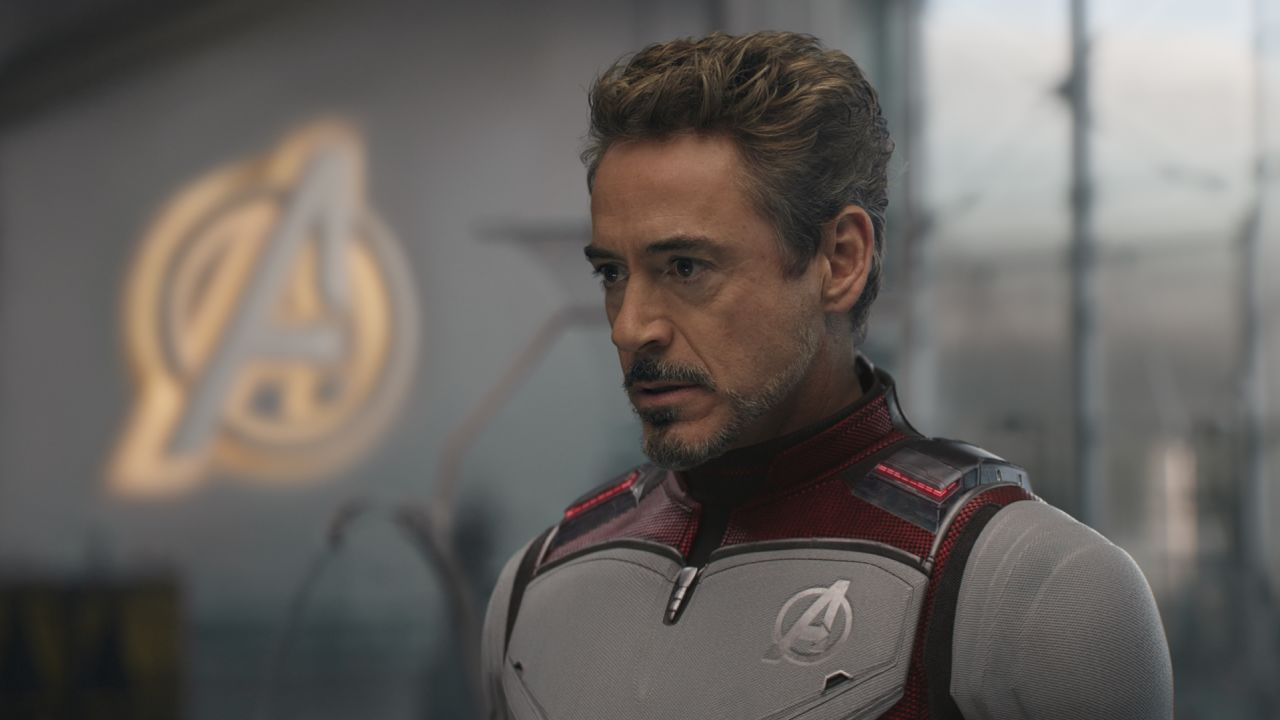What is this photo about? This photo captures a striking image of Tony Stark, a character from the Marvel Cinematic Universe, portrayed by Robert Downey Jr. He is dressed in his distinctive Avengers suit, which is carefully detailed with the iconic Avengers logo on the chest. Behind him, the blurred Avengers' emblem reinforces the theme of unity and heroism. His expression, focused and serious, reflects the complex emotions and responsibilities of his character within the series. This setting suggests a pivotal moment, likely related to the overarching narrative of sacrifice and teamwork. 